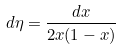Convert formula to latex. <formula><loc_0><loc_0><loc_500><loc_500>d \eta = \frac { d x } { 2 x ( 1 - x ) }</formula> 